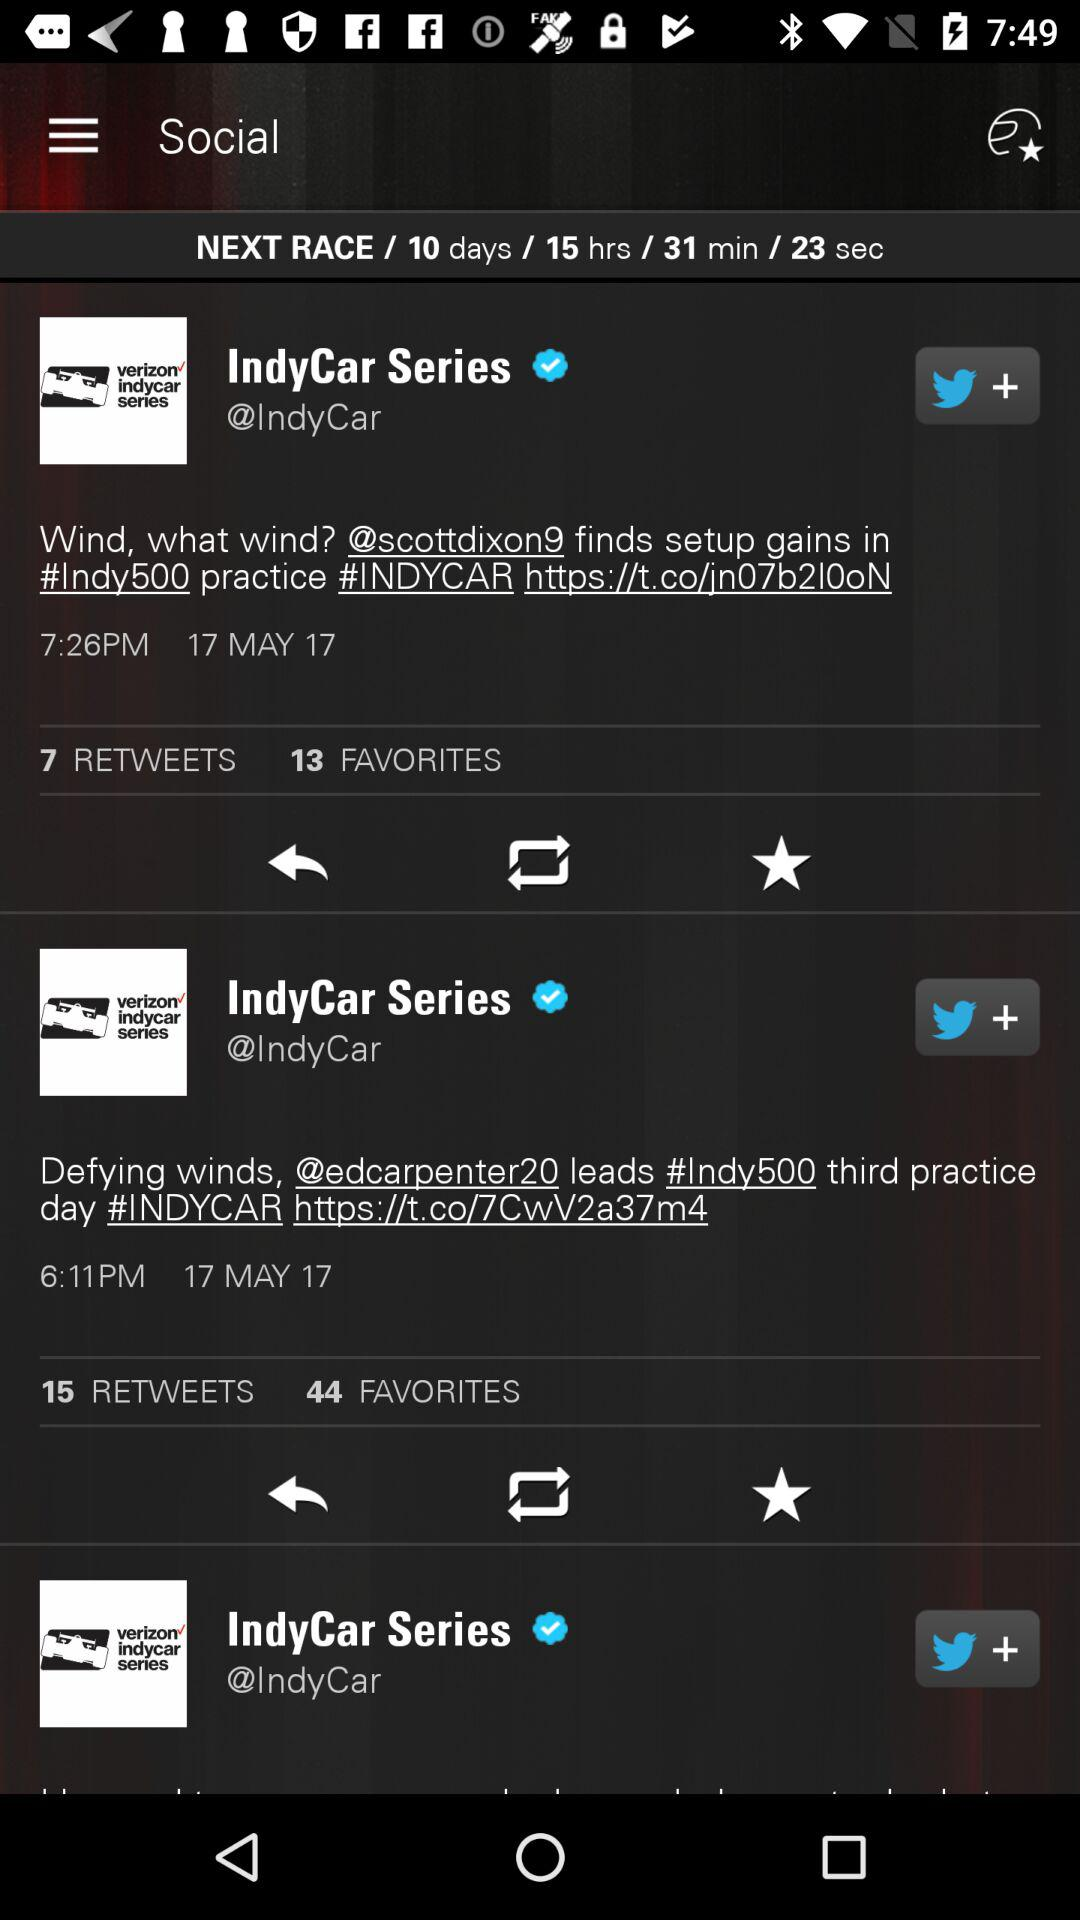How many favorites are on the post posted by "IndyCar Series" at 7:26 PM? There are 13 favorites on the post posted by "IndyCar Series" at 7:26 PM. 